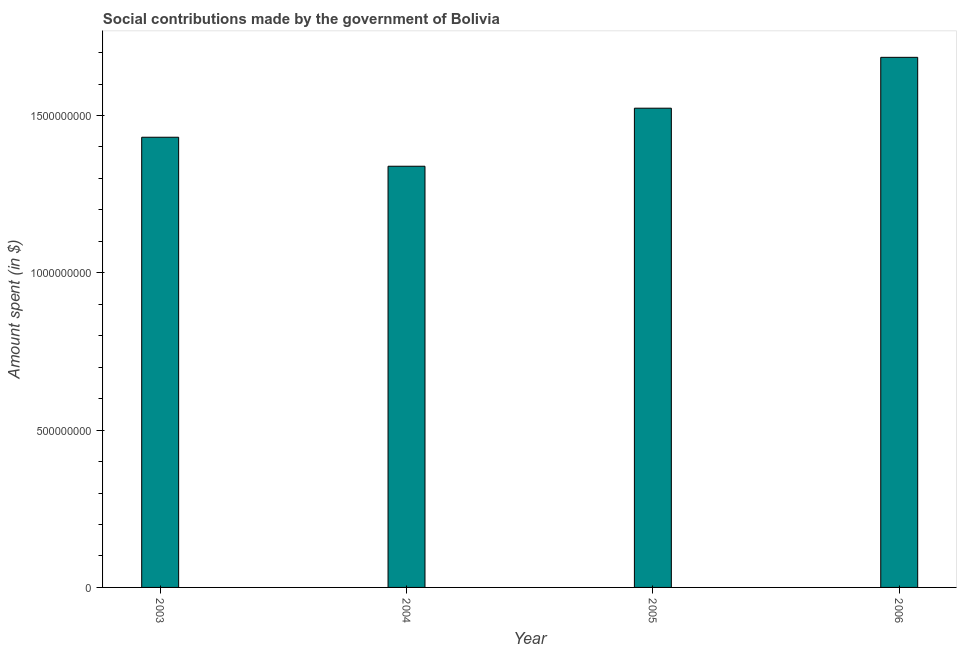Does the graph contain grids?
Give a very brief answer. No. What is the title of the graph?
Offer a terse response. Social contributions made by the government of Bolivia. What is the label or title of the Y-axis?
Keep it short and to the point. Amount spent (in $). What is the amount spent in making social contributions in 2005?
Offer a terse response. 1.52e+09. Across all years, what is the maximum amount spent in making social contributions?
Provide a short and direct response. 1.68e+09. Across all years, what is the minimum amount spent in making social contributions?
Keep it short and to the point. 1.34e+09. What is the sum of the amount spent in making social contributions?
Make the answer very short. 5.98e+09. What is the difference between the amount spent in making social contributions in 2003 and 2005?
Provide a succinct answer. -9.23e+07. What is the average amount spent in making social contributions per year?
Give a very brief answer. 1.49e+09. What is the median amount spent in making social contributions?
Provide a short and direct response. 1.48e+09. In how many years, is the amount spent in making social contributions greater than 1000000000 $?
Provide a short and direct response. 4. What is the ratio of the amount spent in making social contributions in 2003 to that in 2006?
Provide a short and direct response. 0.85. Is the amount spent in making social contributions in 2003 less than that in 2004?
Your answer should be compact. No. What is the difference between the highest and the second highest amount spent in making social contributions?
Ensure brevity in your answer.  1.62e+08. Is the sum of the amount spent in making social contributions in 2004 and 2005 greater than the maximum amount spent in making social contributions across all years?
Provide a succinct answer. Yes. What is the difference between the highest and the lowest amount spent in making social contributions?
Make the answer very short. 3.46e+08. How many years are there in the graph?
Your answer should be very brief. 4. Are the values on the major ticks of Y-axis written in scientific E-notation?
Offer a terse response. No. What is the Amount spent (in $) in 2003?
Your answer should be compact. 1.43e+09. What is the Amount spent (in $) of 2004?
Your answer should be very brief. 1.34e+09. What is the Amount spent (in $) in 2005?
Make the answer very short. 1.52e+09. What is the Amount spent (in $) in 2006?
Offer a terse response. 1.68e+09. What is the difference between the Amount spent (in $) in 2003 and 2004?
Offer a very short reply. 9.22e+07. What is the difference between the Amount spent (in $) in 2003 and 2005?
Keep it short and to the point. -9.23e+07. What is the difference between the Amount spent (in $) in 2003 and 2006?
Ensure brevity in your answer.  -2.54e+08. What is the difference between the Amount spent (in $) in 2004 and 2005?
Keep it short and to the point. -1.84e+08. What is the difference between the Amount spent (in $) in 2004 and 2006?
Your answer should be very brief. -3.46e+08. What is the difference between the Amount spent (in $) in 2005 and 2006?
Provide a short and direct response. -1.62e+08. What is the ratio of the Amount spent (in $) in 2003 to that in 2004?
Offer a very short reply. 1.07. What is the ratio of the Amount spent (in $) in 2003 to that in 2005?
Provide a succinct answer. 0.94. What is the ratio of the Amount spent (in $) in 2003 to that in 2006?
Your response must be concise. 0.85. What is the ratio of the Amount spent (in $) in 2004 to that in 2005?
Provide a short and direct response. 0.88. What is the ratio of the Amount spent (in $) in 2004 to that in 2006?
Offer a terse response. 0.8. What is the ratio of the Amount spent (in $) in 2005 to that in 2006?
Give a very brief answer. 0.9. 